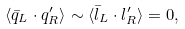<formula> <loc_0><loc_0><loc_500><loc_500>\langle \bar { q } _ { L } \cdot q ^ { \prime } _ { R } \rangle \sim \langle \bar { l } _ { L } \cdot l ^ { \prime } _ { R } \rangle = 0 ,</formula> 